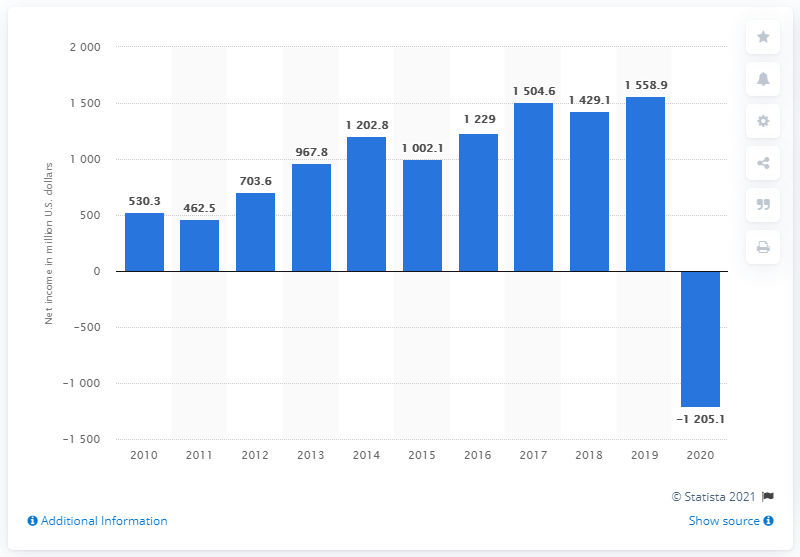Give some essential details in this illustration. Ecolab Inc.'s net loss in 2020 was approximately $120.28 million. 